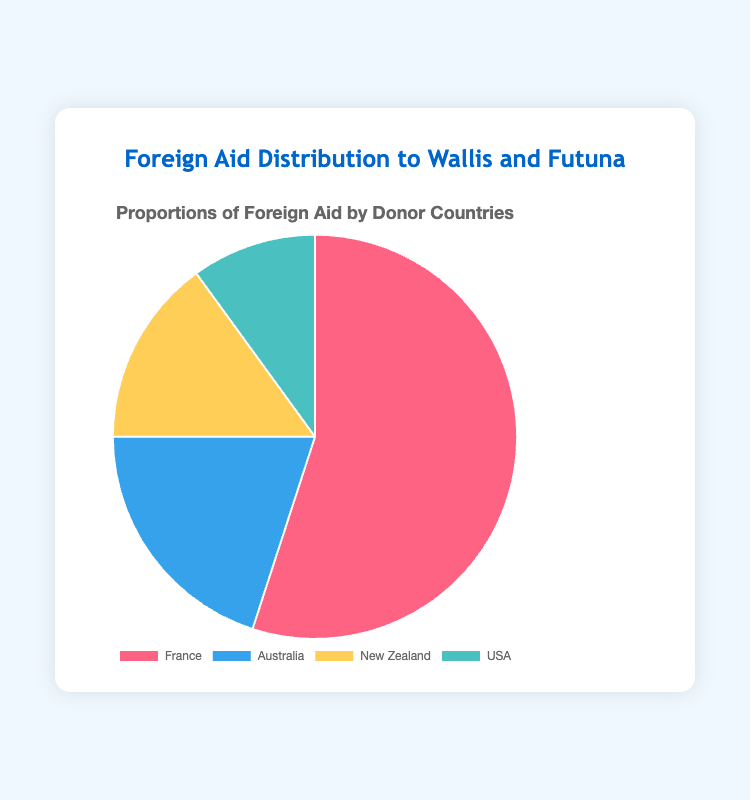What percentage of foreign aid to Wallis and Futuna comes from France? According to the pie chart, France contributes 55% to the total foreign aid to Wallis and Futuna.
Answer: 55% Which country provides the smallest proportion of foreign aid to Wallis and Futuna? The pie chart shows that the USA provides the smallest proportion of foreign aid at 10%.
Answer: USA How much more foreign aid does France provide compared to New Zealand? The percentage of aid from France is 55%, and from New Zealand is 15%. The difference is 55% - 15% = 40%.
Answer: 40% If New Zealand and Australia combined their foreign aid contributions, what percentage would that be? New Zealand contributes 15% and Australia 20%. Together, their contribution would be 15% + 20% = 35%.
Answer: 35% Compare the contributions of France and Australia. Is France's contribution more than double that of Australia's? France provides 55%, whereas Australia provides 20%. Double of Australia’s contribution is 20% x 2 = 40%. Since 55% > 40%, France's contribution is indeed more than double that of Australia's.
Answer: Yes What is the sum of the proportions of foreign aid provided by countries other than France? Adding the percentages from Australia (20%), New Zealand (15%), and the USA (10%): 20% + 15% + 10% = 45%.
Answer: 45% What is the average contribution percentage of the four donor countries? Adding all contributions: 55% (France) + 20% (Australia) + 15% (New Zealand) + 10% (USA) = 100%. The average is 100% / 4 = 25%.
Answer: 25% Which color represents the foreign aid provided by the USA? The chart uses specific colors for each country. The portion representing the USA is colored in teal (a shade of blue-green).
Answer: Teal 